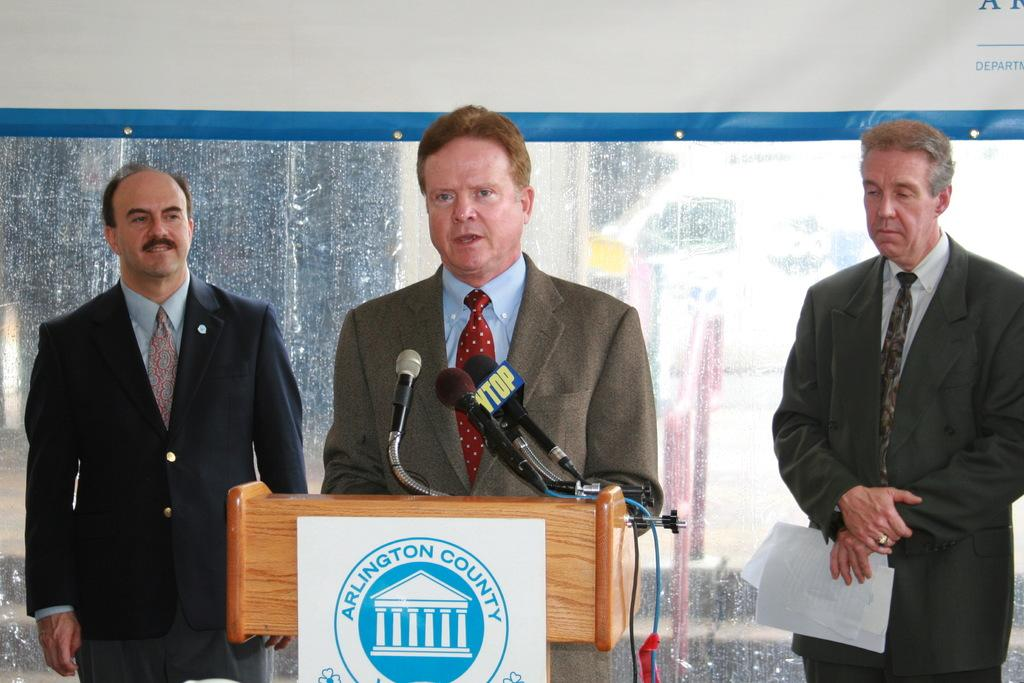What is the man in the middle of the image wearing? The man in the middle of the image is wearing a grey suit. What is the man in the grey suit doing in the image? The man in the grey suit is talking on a microphone. How many men in suits are present behind the man in the grey suit? There are two men in suits behind the man in the grey suit. Where are the two men in suits positioned in relation to the man in the grey suit? The two men in suits are standing on either side of the man in the grey suit. What can be seen behind the men in the image? There is a glass window behind the men. What type of plate is the man in the grey suit holding in the image? There is no plate present in the image; the man in the grey suit is talking on a microphone. 